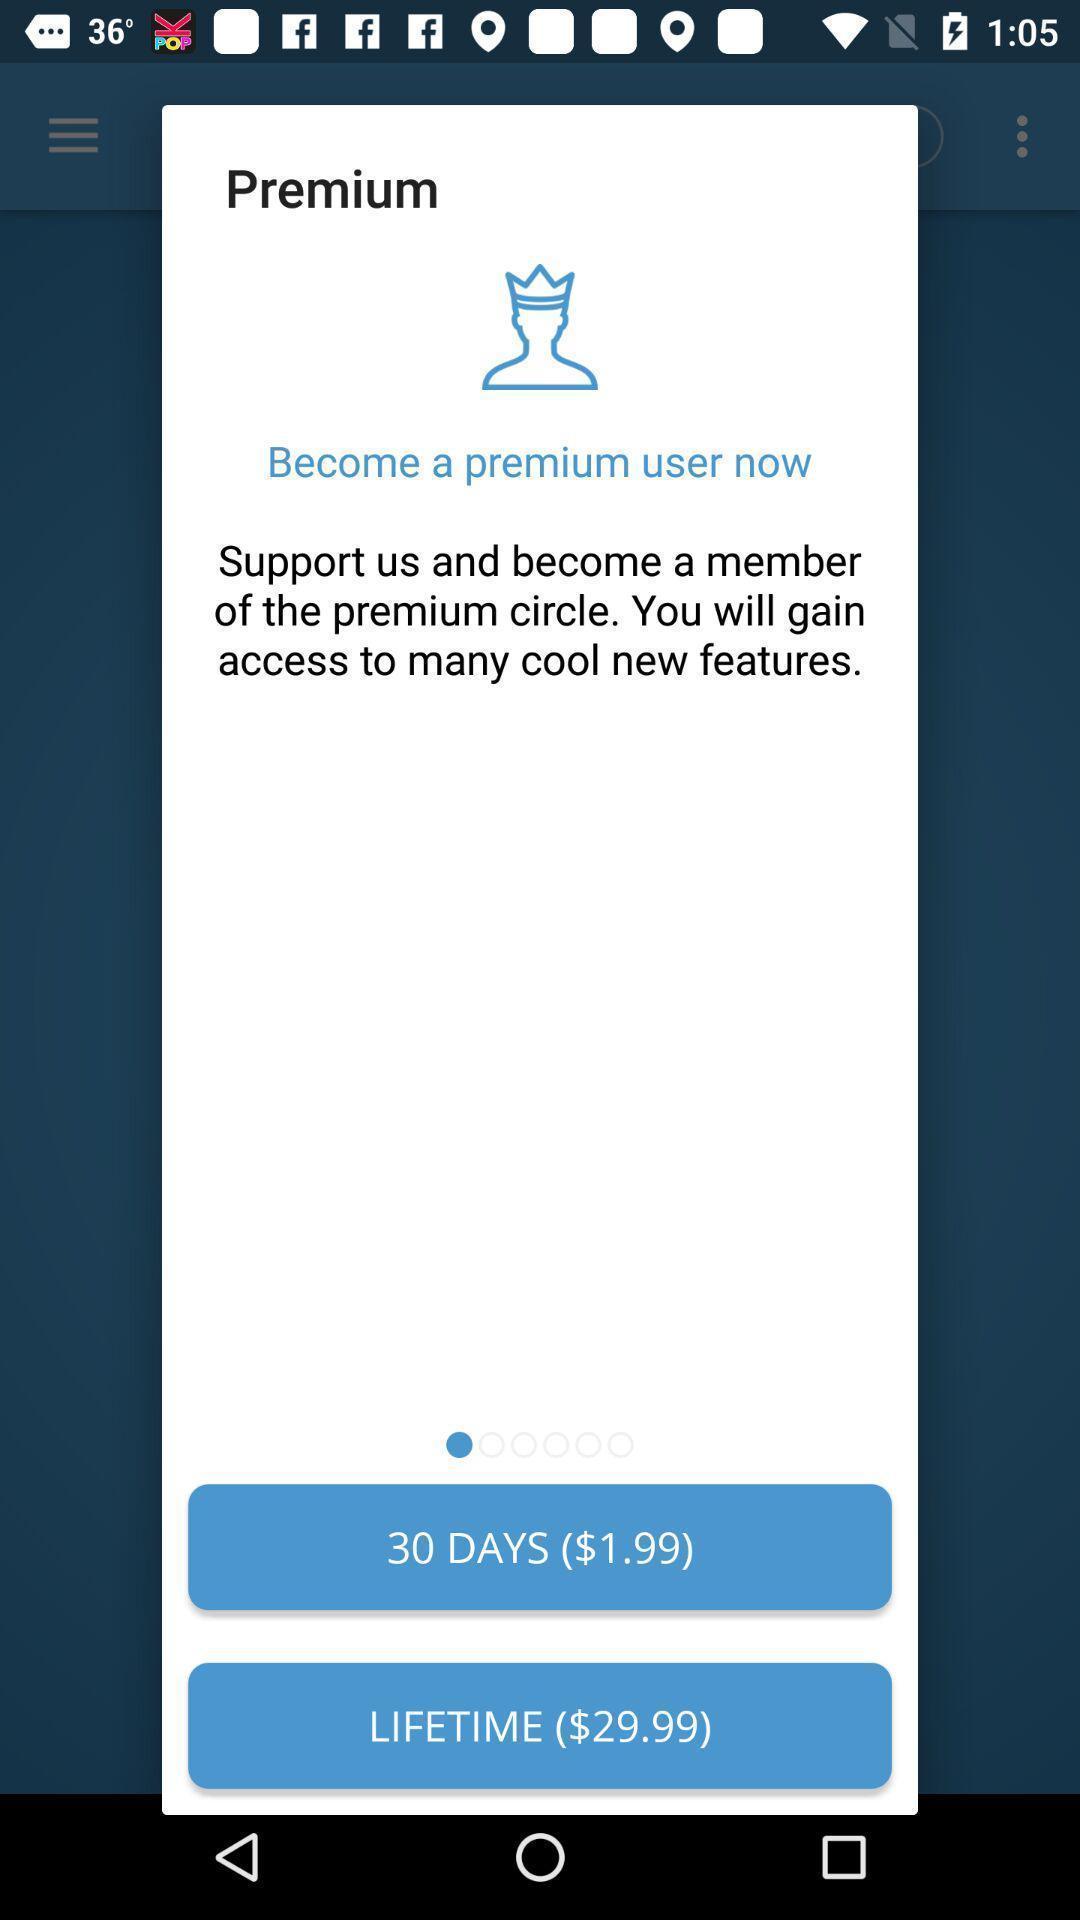Summarize the main components in this picture. Pop-up window showing cost details for premium users. 